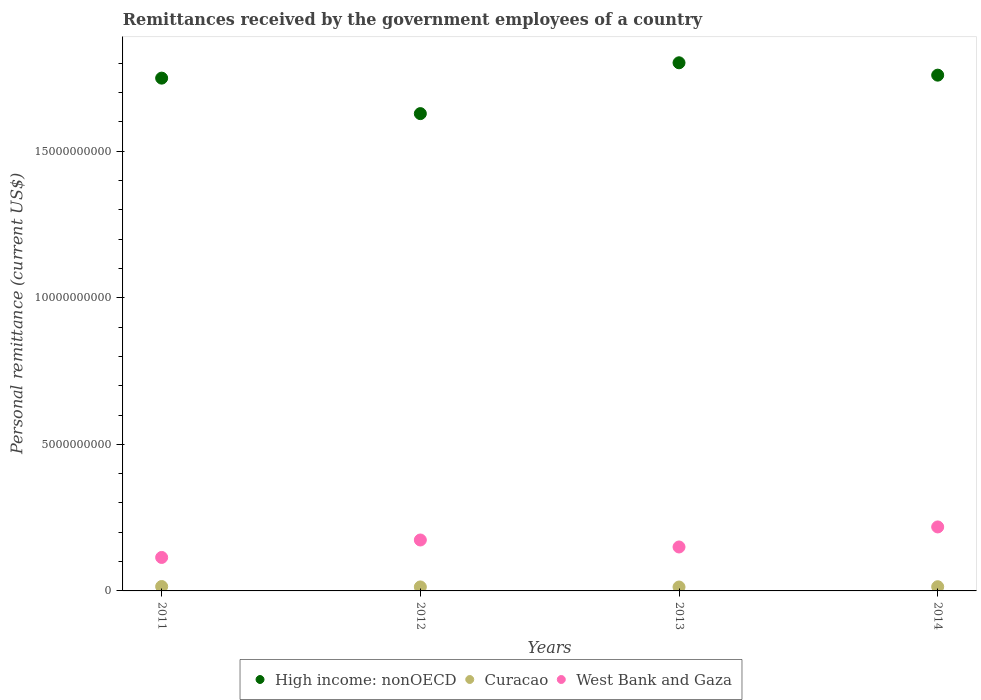What is the remittances received by the government employees in West Bank and Gaza in 2014?
Keep it short and to the point. 2.18e+09. Across all years, what is the maximum remittances received by the government employees in West Bank and Gaza?
Give a very brief answer. 2.18e+09. Across all years, what is the minimum remittances received by the government employees in High income: nonOECD?
Your response must be concise. 1.63e+1. In which year was the remittances received by the government employees in West Bank and Gaza maximum?
Make the answer very short. 2014. What is the total remittances received by the government employees in Curacao in the graph?
Offer a terse response. 5.62e+08. What is the difference between the remittances received by the government employees in Curacao in 2012 and that in 2013?
Keep it short and to the point. 2.91e+06. What is the difference between the remittances received by the government employees in Curacao in 2011 and the remittances received by the government employees in West Bank and Gaza in 2012?
Provide a short and direct response. -1.59e+09. What is the average remittances received by the government employees in Curacao per year?
Your answer should be compact. 1.41e+08. In the year 2013, what is the difference between the remittances received by the government employees in Curacao and remittances received by the government employees in West Bank and Gaza?
Make the answer very short. -1.37e+09. In how many years, is the remittances received by the government employees in West Bank and Gaza greater than 5000000000 US$?
Ensure brevity in your answer.  0. What is the ratio of the remittances received by the government employees in High income: nonOECD in 2011 to that in 2014?
Keep it short and to the point. 0.99. Is the remittances received by the government employees in High income: nonOECD in 2011 less than that in 2013?
Your answer should be compact. Yes. Is the difference between the remittances received by the government employees in Curacao in 2013 and 2014 greater than the difference between the remittances received by the government employees in West Bank and Gaza in 2013 and 2014?
Give a very brief answer. Yes. What is the difference between the highest and the second highest remittances received by the government employees in High income: nonOECD?
Offer a very short reply. 4.22e+08. What is the difference between the highest and the lowest remittances received by the government employees in High income: nonOECD?
Offer a terse response. 1.73e+09. Does the remittances received by the government employees in Curacao monotonically increase over the years?
Offer a very short reply. No. Is the remittances received by the government employees in High income: nonOECD strictly greater than the remittances received by the government employees in West Bank and Gaza over the years?
Offer a very short reply. Yes. What is the difference between two consecutive major ticks on the Y-axis?
Provide a short and direct response. 5.00e+09. Does the graph contain grids?
Offer a very short reply. No. How are the legend labels stacked?
Offer a very short reply. Horizontal. What is the title of the graph?
Ensure brevity in your answer.  Remittances received by the government employees of a country. Does "Oman" appear as one of the legend labels in the graph?
Your answer should be very brief. No. What is the label or title of the Y-axis?
Your answer should be compact. Personal remittance (current US$). What is the Personal remittance (current US$) in High income: nonOECD in 2011?
Offer a very short reply. 1.75e+1. What is the Personal remittance (current US$) in Curacao in 2011?
Give a very brief answer. 1.50e+08. What is the Personal remittance (current US$) of West Bank and Gaza in 2011?
Provide a succinct answer. 1.14e+09. What is the Personal remittance (current US$) of High income: nonOECD in 2012?
Your answer should be compact. 1.63e+1. What is the Personal remittance (current US$) of Curacao in 2012?
Ensure brevity in your answer.  1.36e+08. What is the Personal remittance (current US$) in West Bank and Gaza in 2012?
Your answer should be compact. 1.74e+09. What is the Personal remittance (current US$) in High income: nonOECD in 2013?
Provide a short and direct response. 1.80e+1. What is the Personal remittance (current US$) in Curacao in 2013?
Offer a terse response. 1.33e+08. What is the Personal remittance (current US$) in West Bank and Gaza in 2013?
Make the answer very short. 1.50e+09. What is the Personal remittance (current US$) in High income: nonOECD in 2014?
Your answer should be very brief. 1.76e+1. What is the Personal remittance (current US$) of Curacao in 2014?
Keep it short and to the point. 1.43e+08. What is the Personal remittance (current US$) in West Bank and Gaza in 2014?
Provide a short and direct response. 2.18e+09. Across all years, what is the maximum Personal remittance (current US$) in High income: nonOECD?
Give a very brief answer. 1.80e+1. Across all years, what is the maximum Personal remittance (current US$) in Curacao?
Offer a terse response. 1.50e+08. Across all years, what is the maximum Personal remittance (current US$) of West Bank and Gaza?
Make the answer very short. 2.18e+09. Across all years, what is the minimum Personal remittance (current US$) in High income: nonOECD?
Your response must be concise. 1.63e+1. Across all years, what is the minimum Personal remittance (current US$) in Curacao?
Offer a very short reply. 1.33e+08. Across all years, what is the minimum Personal remittance (current US$) in West Bank and Gaza?
Your response must be concise. 1.14e+09. What is the total Personal remittance (current US$) in High income: nonOECD in the graph?
Offer a very short reply. 6.94e+1. What is the total Personal remittance (current US$) in Curacao in the graph?
Your answer should be compact. 5.62e+08. What is the total Personal remittance (current US$) in West Bank and Gaza in the graph?
Offer a very short reply. 6.56e+09. What is the difference between the Personal remittance (current US$) of High income: nonOECD in 2011 and that in 2012?
Provide a short and direct response. 1.21e+09. What is the difference between the Personal remittance (current US$) of Curacao in 2011 and that in 2012?
Give a very brief answer. 1.42e+07. What is the difference between the Personal remittance (current US$) in West Bank and Gaza in 2011 and that in 2012?
Provide a short and direct response. -5.95e+08. What is the difference between the Personal remittance (current US$) of High income: nonOECD in 2011 and that in 2013?
Your answer should be very brief. -5.24e+08. What is the difference between the Personal remittance (current US$) in Curacao in 2011 and that in 2013?
Provide a short and direct response. 1.71e+07. What is the difference between the Personal remittance (current US$) in West Bank and Gaza in 2011 and that in 2013?
Ensure brevity in your answer.  -3.57e+08. What is the difference between the Personal remittance (current US$) in High income: nonOECD in 2011 and that in 2014?
Provide a succinct answer. -1.02e+08. What is the difference between the Personal remittance (current US$) in Curacao in 2011 and that in 2014?
Give a very brief answer. 6.85e+06. What is the difference between the Personal remittance (current US$) in West Bank and Gaza in 2011 and that in 2014?
Give a very brief answer. -1.04e+09. What is the difference between the Personal remittance (current US$) of High income: nonOECD in 2012 and that in 2013?
Offer a terse response. -1.73e+09. What is the difference between the Personal remittance (current US$) in Curacao in 2012 and that in 2013?
Your answer should be very brief. 2.91e+06. What is the difference between the Personal remittance (current US$) in West Bank and Gaza in 2012 and that in 2013?
Your response must be concise. 2.38e+08. What is the difference between the Personal remittance (current US$) of High income: nonOECD in 2012 and that in 2014?
Make the answer very short. -1.31e+09. What is the difference between the Personal remittance (current US$) of Curacao in 2012 and that in 2014?
Your answer should be very brief. -7.31e+06. What is the difference between the Personal remittance (current US$) of West Bank and Gaza in 2012 and that in 2014?
Provide a short and direct response. -4.45e+08. What is the difference between the Personal remittance (current US$) in High income: nonOECD in 2013 and that in 2014?
Provide a succinct answer. 4.22e+08. What is the difference between the Personal remittance (current US$) of Curacao in 2013 and that in 2014?
Your answer should be compact. -1.02e+07. What is the difference between the Personal remittance (current US$) of West Bank and Gaza in 2013 and that in 2014?
Ensure brevity in your answer.  -6.84e+08. What is the difference between the Personal remittance (current US$) in High income: nonOECD in 2011 and the Personal remittance (current US$) in Curacao in 2012?
Ensure brevity in your answer.  1.74e+1. What is the difference between the Personal remittance (current US$) in High income: nonOECD in 2011 and the Personal remittance (current US$) in West Bank and Gaza in 2012?
Your answer should be compact. 1.58e+1. What is the difference between the Personal remittance (current US$) of Curacao in 2011 and the Personal remittance (current US$) of West Bank and Gaza in 2012?
Ensure brevity in your answer.  -1.59e+09. What is the difference between the Personal remittance (current US$) of High income: nonOECD in 2011 and the Personal remittance (current US$) of Curacao in 2013?
Offer a very short reply. 1.74e+1. What is the difference between the Personal remittance (current US$) in High income: nonOECD in 2011 and the Personal remittance (current US$) in West Bank and Gaza in 2013?
Your response must be concise. 1.60e+1. What is the difference between the Personal remittance (current US$) of Curacao in 2011 and the Personal remittance (current US$) of West Bank and Gaza in 2013?
Your answer should be compact. -1.35e+09. What is the difference between the Personal remittance (current US$) of High income: nonOECD in 2011 and the Personal remittance (current US$) of Curacao in 2014?
Make the answer very short. 1.73e+1. What is the difference between the Personal remittance (current US$) of High income: nonOECD in 2011 and the Personal remittance (current US$) of West Bank and Gaza in 2014?
Your answer should be compact. 1.53e+1. What is the difference between the Personal remittance (current US$) in Curacao in 2011 and the Personal remittance (current US$) in West Bank and Gaza in 2014?
Provide a short and direct response. -2.03e+09. What is the difference between the Personal remittance (current US$) in High income: nonOECD in 2012 and the Personal remittance (current US$) in Curacao in 2013?
Keep it short and to the point. 1.61e+1. What is the difference between the Personal remittance (current US$) in High income: nonOECD in 2012 and the Personal remittance (current US$) in West Bank and Gaza in 2013?
Your response must be concise. 1.48e+1. What is the difference between the Personal remittance (current US$) of Curacao in 2012 and the Personal remittance (current US$) of West Bank and Gaza in 2013?
Offer a very short reply. -1.36e+09. What is the difference between the Personal remittance (current US$) in High income: nonOECD in 2012 and the Personal remittance (current US$) in Curacao in 2014?
Make the answer very short. 1.61e+1. What is the difference between the Personal remittance (current US$) in High income: nonOECD in 2012 and the Personal remittance (current US$) in West Bank and Gaza in 2014?
Ensure brevity in your answer.  1.41e+1. What is the difference between the Personal remittance (current US$) of Curacao in 2012 and the Personal remittance (current US$) of West Bank and Gaza in 2014?
Make the answer very short. -2.05e+09. What is the difference between the Personal remittance (current US$) of High income: nonOECD in 2013 and the Personal remittance (current US$) of Curacao in 2014?
Give a very brief answer. 1.79e+1. What is the difference between the Personal remittance (current US$) in High income: nonOECD in 2013 and the Personal remittance (current US$) in West Bank and Gaza in 2014?
Give a very brief answer. 1.58e+1. What is the difference between the Personal remittance (current US$) in Curacao in 2013 and the Personal remittance (current US$) in West Bank and Gaza in 2014?
Provide a short and direct response. -2.05e+09. What is the average Personal remittance (current US$) in High income: nonOECD per year?
Keep it short and to the point. 1.73e+1. What is the average Personal remittance (current US$) in Curacao per year?
Provide a short and direct response. 1.41e+08. What is the average Personal remittance (current US$) in West Bank and Gaza per year?
Your response must be concise. 1.64e+09. In the year 2011, what is the difference between the Personal remittance (current US$) in High income: nonOECD and Personal remittance (current US$) in Curacao?
Keep it short and to the point. 1.73e+1. In the year 2011, what is the difference between the Personal remittance (current US$) in High income: nonOECD and Personal remittance (current US$) in West Bank and Gaza?
Keep it short and to the point. 1.63e+1. In the year 2011, what is the difference between the Personal remittance (current US$) of Curacao and Personal remittance (current US$) of West Bank and Gaza?
Provide a succinct answer. -9.92e+08. In the year 2012, what is the difference between the Personal remittance (current US$) in High income: nonOECD and Personal remittance (current US$) in Curacao?
Offer a terse response. 1.61e+1. In the year 2012, what is the difference between the Personal remittance (current US$) of High income: nonOECD and Personal remittance (current US$) of West Bank and Gaza?
Make the answer very short. 1.45e+1. In the year 2012, what is the difference between the Personal remittance (current US$) of Curacao and Personal remittance (current US$) of West Bank and Gaza?
Keep it short and to the point. -1.60e+09. In the year 2013, what is the difference between the Personal remittance (current US$) of High income: nonOECD and Personal remittance (current US$) of Curacao?
Give a very brief answer. 1.79e+1. In the year 2013, what is the difference between the Personal remittance (current US$) in High income: nonOECD and Personal remittance (current US$) in West Bank and Gaza?
Make the answer very short. 1.65e+1. In the year 2013, what is the difference between the Personal remittance (current US$) in Curacao and Personal remittance (current US$) in West Bank and Gaza?
Offer a very short reply. -1.37e+09. In the year 2014, what is the difference between the Personal remittance (current US$) of High income: nonOECD and Personal remittance (current US$) of Curacao?
Your response must be concise. 1.74e+1. In the year 2014, what is the difference between the Personal remittance (current US$) of High income: nonOECD and Personal remittance (current US$) of West Bank and Gaza?
Ensure brevity in your answer.  1.54e+1. In the year 2014, what is the difference between the Personal remittance (current US$) in Curacao and Personal remittance (current US$) in West Bank and Gaza?
Keep it short and to the point. -2.04e+09. What is the ratio of the Personal remittance (current US$) in High income: nonOECD in 2011 to that in 2012?
Your answer should be compact. 1.07. What is the ratio of the Personal remittance (current US$) of Curacao in 2011 to that in 2012?
Offer a very short reply. 1.1. What is the ratio of the Personal remittance (current US$) in West Bank and Gaza in 2011 to that in 2012?
Your answer should be compact. 0.66. What is the ratio of the Personal remittance (current US$) of High income: nonOECD in 2011 to that in 2013?
Offer a terse response. 0.97. What is the ratio of the Personal remittance (current US$) in Curacao in 2011 to that in 2013?
Your answer should be very brief. 1.13. What is the ratio of the Personal remittance (current US$) of West Bank and Gaza in 2011 to that in 2013?
Your response must be concise. 0.76. What is the ratio of the Personal remittance (current US$) of High income: nonOECD in 2011 to that in 2014?
Ensure brevity in your answer.  0.99. What is the ratio of the Personal remittance (current US$) of Curacao in 2011 to that in 2014?
Ensure brevity in your answer.  1.05. What is the ratio of the Personal remittance (current US$) of West Bank and Gaza in 2011 to that in 2014?
Your answer should be very brief. 0.52. What is the ratio of the Personal remittance (current US$) of High income: nonOECD in 2012 to that in 2013?
Your response must be concise. 0.9. What is the ratio of the Personal remittance (current US$) of Curacao in 2012 to that in 2013?
Ensure brevity in your answer.  1.02. What is the ratio of the Personal remittance (current US$) in West Bank and Gaza in 2012 to that in 2013?
Your response must be concise. 1.16. What is the ratio of the Personal remittance (current US$) in High income: nonOECD in 2012 to that in 2014?
Keep it short and to the point. 0.93. What is the ratio of the Personal remittance (current US$) of Curacao in 2012 to that in 2014?
Provide a short and direct response. 0.95. What is the ratio of the Personal remittance (current US$) in West Bank and Gaza in 2012 to that in 2014?
Provide a short and direct response. 0.8. What is the ratio of the Personal remittance (current US$) in High income: nonOECD in 2013 to that in 2014?
Provide a succinct answer. 1.02. What is the ratio of the Personal remittance (current US$) of Curacao in 2013 to that in 2014?
Provide a short and direct response. 0.93. What is the ratio of the Personal remittance (current US$) in West Bank and Gaza in 2013 to that in 2014?
Provide a succinct answer. 0.69. What is the difference between the highest and the second highest Personal remittance (current US$) in High income: nonOECD?
Offer a very short reply. 4.22e+08. What is the difference between the highest and the second highest Personal remittance (current US$) of Curacao?
Your answer should be very brief. 6.85e+06. What is the difference between the highest and the second highest Personal remittance (current US$) in West Bank and Gaza?
Offer a terse response. 4.45e+08. What is the difference between the highest and the lowest Personal remittance (current US$) of High income: nonOECD?
Offer a very short reply. 1.73e+09. What is the difference between the highest and the lowest Personal remittance (current US$) of Curacao?
Give a very brief answer. 1.71e+07. What is the difference between the highest and the lowest Personal remittance (current US$) in West Bank and Gaza?
Keep it short and to the point. 1.04e+09. 